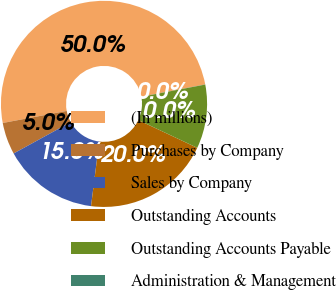<chart> <loc_0><loc_0><loc_500><loc_500><pie_chart><fcel>(In millions)<fcel>Purchases by Company<fcel>Sales by Company<fcel>Outstanding Accounts<fcel>Outstanding Accounts Payable<fcel>Administration & Management<nl><fcel>49.95%<fcel>5.02%<fcel>15.0%<fcel>20.0%<fcel>10.01%<fcel>0.02%<nl></chart> 